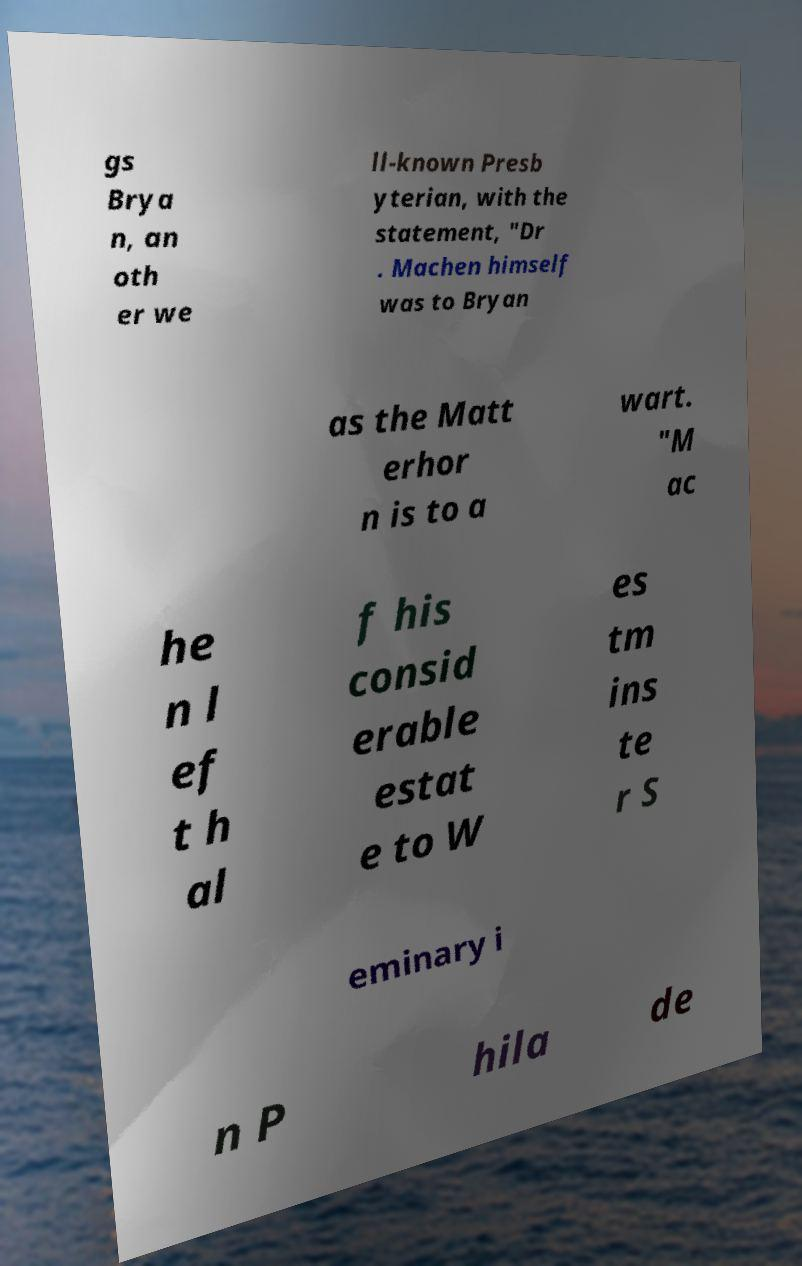Please identify and transcribe the text found in this image. gs Brya n, an oth er we ll-known Presb yterian, with the statement, "Dr . Machen himself was to Bryan as the Matt erhor n is to a wart. "M ac he n l ef t h al f his consid erable estat e to W es tm ins te r S eminary i n P hila de 